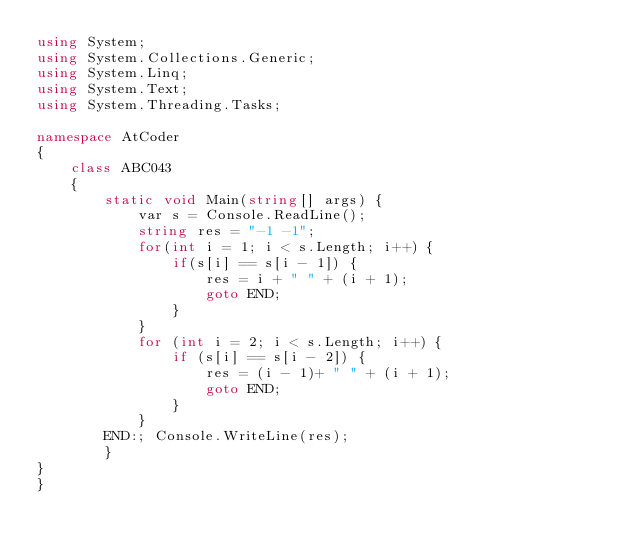<code> <loc_0><loc_0><loc_500><loc_500><_C#_>using System;
using System.Collections.Generic;
using System.Linq;
using System.Text;
using System.Threading.Tasks;

namespace AtCoder
{
    class ABC043
    {
        static void Main(string[] args) {
            var s = Console.ReadLine();
            string res = "-1 -1";
            for(int i = 1; i < s.Length; i++) {
                if(s[i] == s[i - 1]) {
                    res = i + " " + (i + 1);
                    goto END;
                }
            }
            for (int i = 2; i < s.Length; i++) {
                if (s[i] == s[i - 2]) {
                    res = (i - 1)+ " " + (i + 1);
                    goto END;
                }
            }
        END:; Console.WriteLine(res);
        }
}
}</code> 